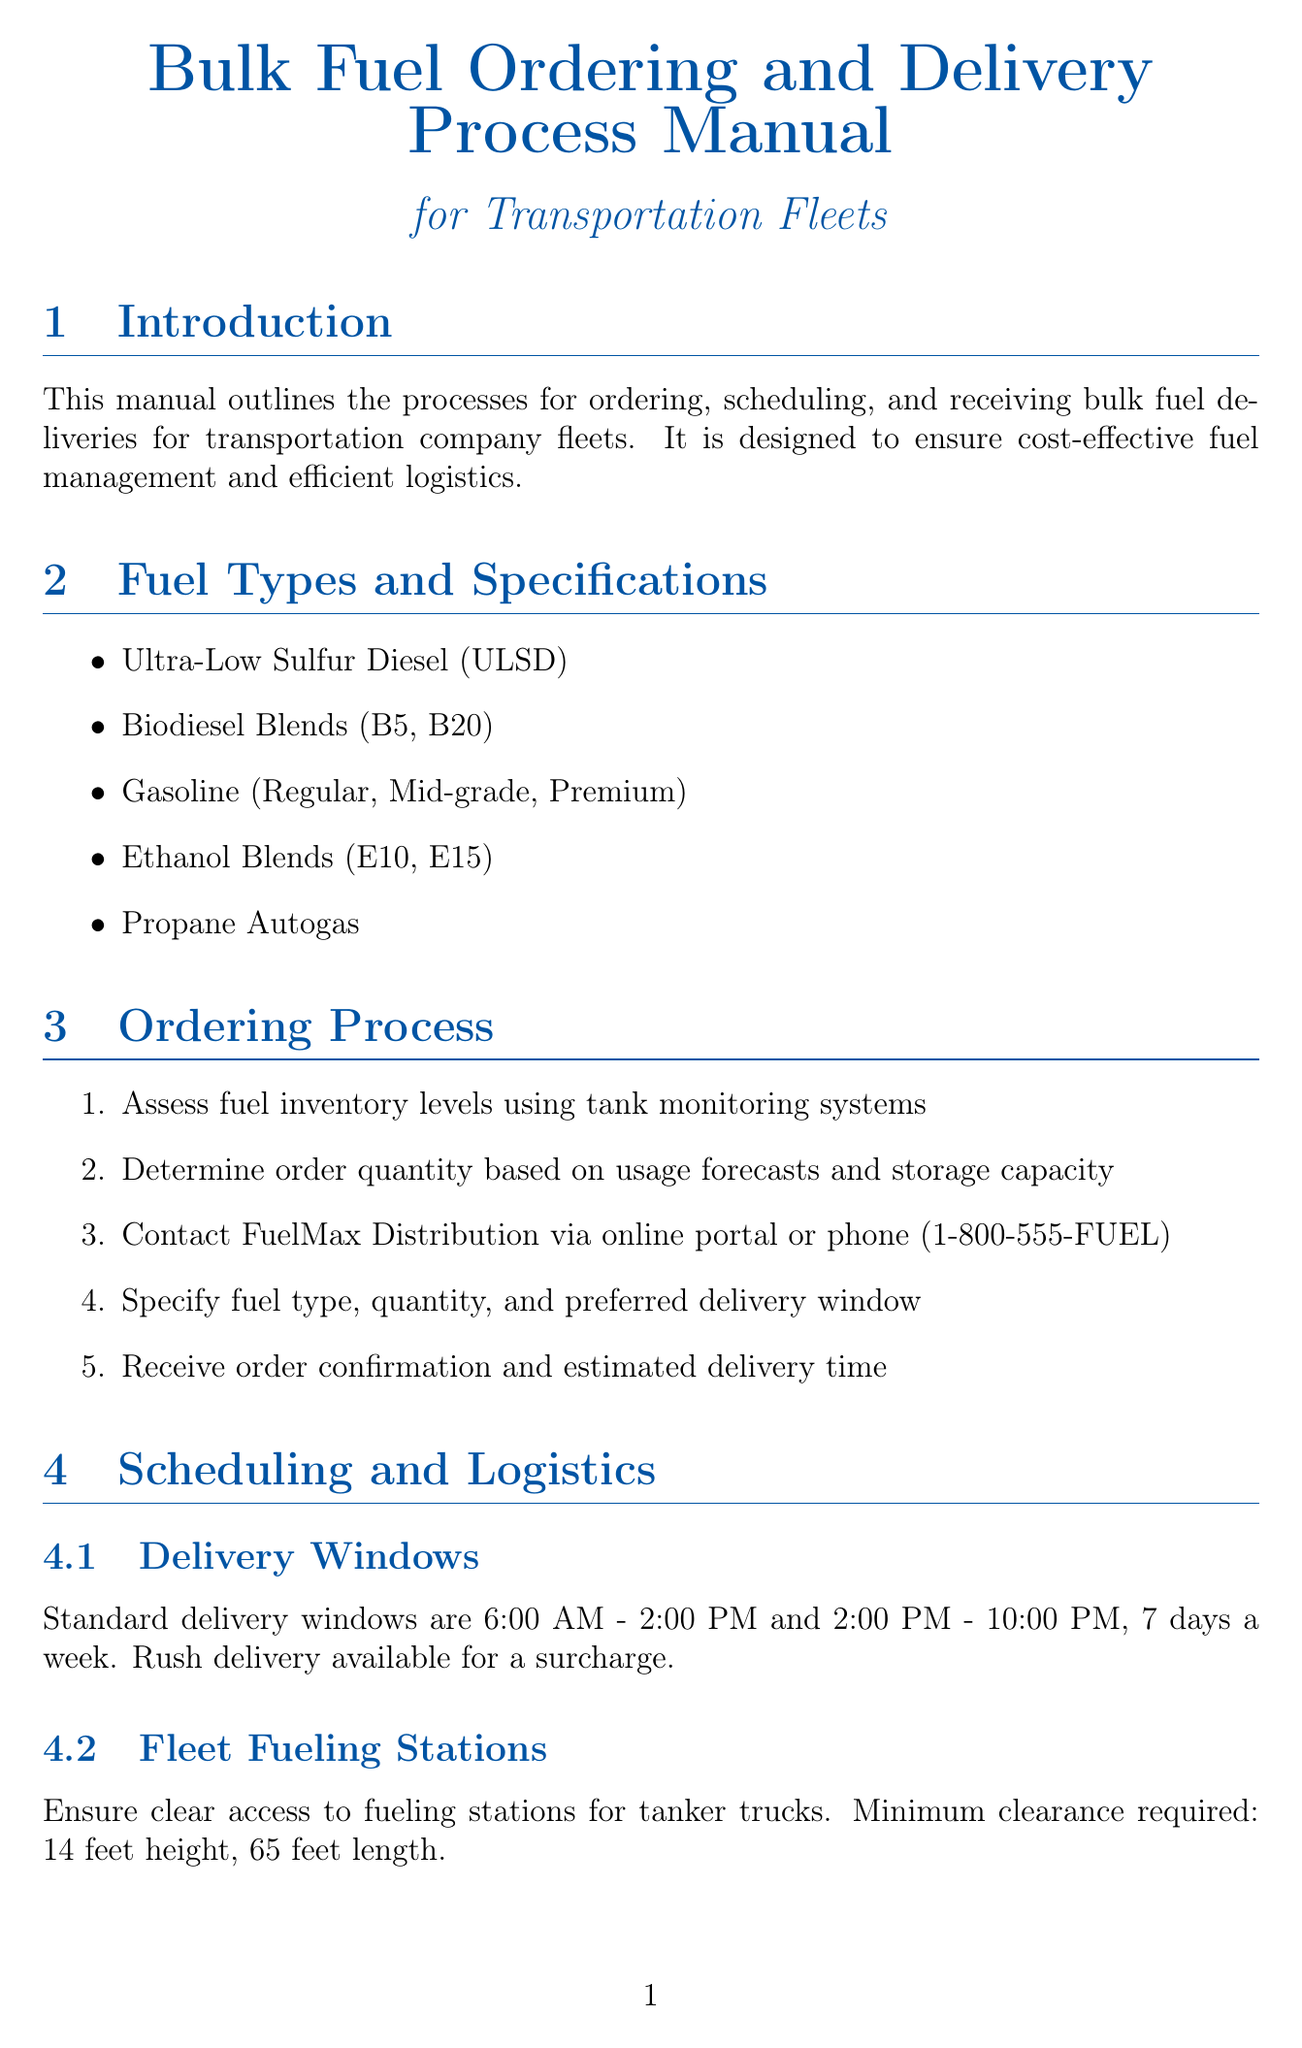What is the title of the manual? The title of the manual is explicitly stated at the beginning: "Bulk Fuel Ordering and Delivery Process Manual for Transportation Fleets."
Answer: Bulk Fuel Ordering and Delivery Process Manual for Transportation Fleets What fuel types are listed in the manual? The section on fuel types includes several options, all listed in the document: ULSD, biodiesel blends, gasoline, ethanol blends, and propane autogas.
Answer: Ultra-Low Sulfur Diesel, Biodiesel Blends, Gasoline, Ethanol Blends, Propane Autogas What is the emergency response contact number? The emergency procedures section provides a specific number for emergencies, which is mentioned in the document.
Answer: 1-888-FUEL-911 What is the volume for volume-based discounts? The payment and billing section specifies a threshold for volume-based discounts in terms of gallons.
Answer: 5,000 gallons When are standard delivery windows? The logistics section details the standard delivery windows and specifies the time ranges for deliveries.
Answer: 6:00 AM - 10:00 PM What is the required clearance height for tanker trucks? The logistics subsection specifies a minimum clearance height required for tanker trucks to access fueling stations.
Answer: 14 feet How often should fuel testing be conducted? The quality control section mentions regular testing by labs but does not specify a frequency; the assumption is ongoing as part of quality control.
Answer: Regularly What software is used for inventory management? The inventory management section identifies a specific software solution used for inventory tracking.
Answer: Fuel-Trac Pro Who is the account manager listed in the contact information? The contact information section provides a specific name for the account manager, including contact details.
Answer: John Smith 